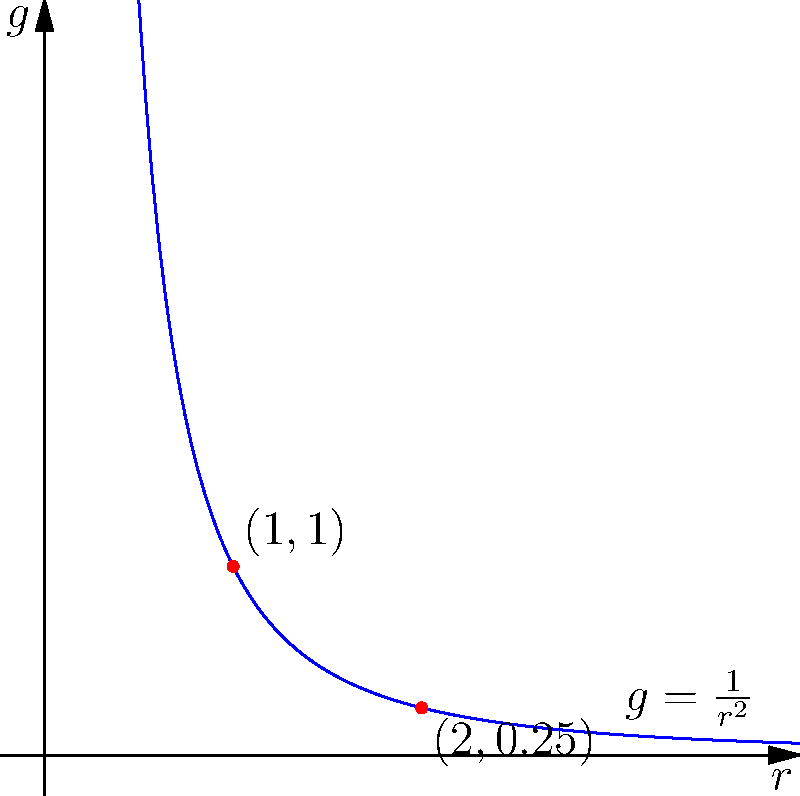A simplified model of the gravitational field strength $g$ near a black hole can be expressed as $g = \frac{GM}{r^2}$, where $G$ is the gravitational constant, $M$ is the mass of the black hole, and $r$ is the distance from the center of the black hole. For a particular black hole, we find that $g = 1$ when $r = 1$ (in appropriate units). Using polar coordinates, calculate the gravitational field strength when $r = 3$. Express your answer as a fraction. Let's approach this step-by-step:

1) We're given that $g = \frac{GM}{r^2}$. This is our general equation.

2) We're also told that when $r = 1$, $g = 1$. Let's use this to find the value of $GM$:

   $1 = \frac{GM}{1^2}$
   $GM = 1$

3) Now that we know $GM = 1$, our equation simplifies to:

   $g = \frac{1}{r^2}$

4) We need to find $g$ when $r = 3$. Let's substitute this into our equation:

   $g = \frac{1}{3^2} = \frac{1}{9}$

5) In polar coordinates, this means that at an angle of $\theta$ (any angle) and a distance of $r = 3$ from the center of the black hole, the gravitational field strength is $\frac{1}{9}$ of what it is at $r = 1$.
Answer: $\frac{1}{9}$ 